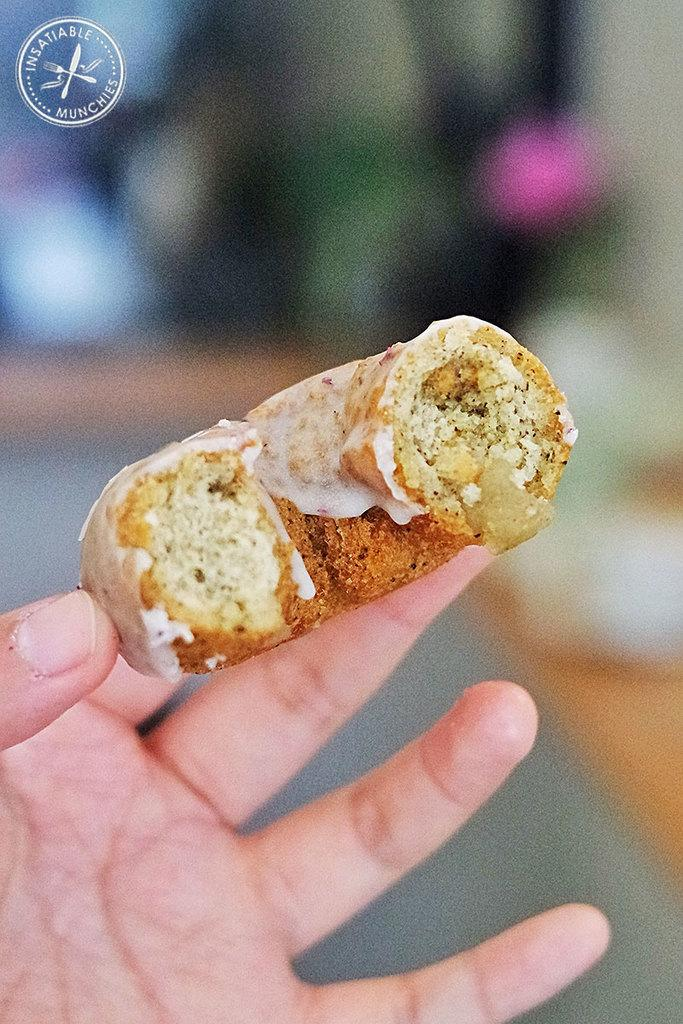What is the person in the image holding? The person is holding food in the image. Can you describe the appearance of the food? The food has brown and white colors. What can be observed about the background of the image? The background of the image is blurred. Is there any additional information or marking on the image? Yes, there is a watermark on the image. How many cards are being used to express love in the image? There are no cards or expressions of love present in the image; it features a person holding food with a blurred background and a watermark. 